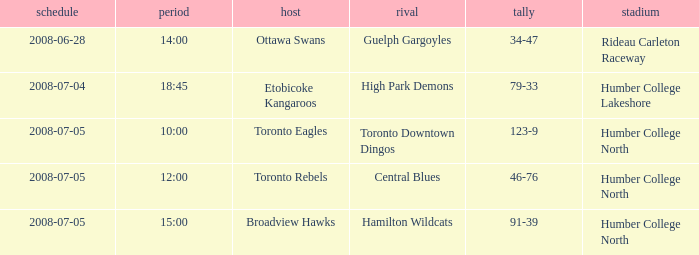What is the Score with a Date that is 2008-06-28? 34-47. 